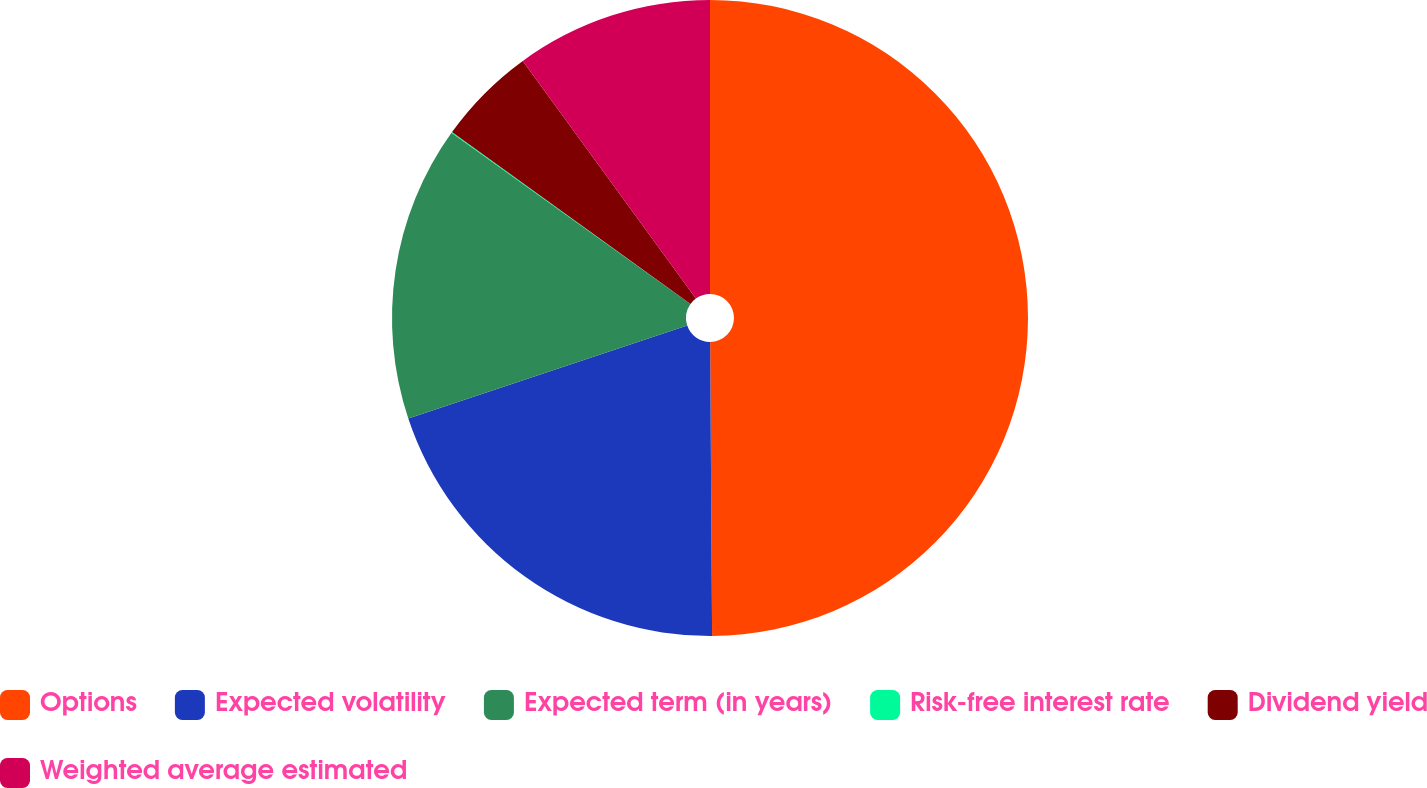Convert chart. <chart><loc_0><loc_0><loc_500><loc_500><pie_chart><fcel>Options<fcel>Expected volatility<fcel>Expected term (in years)<fcel>Risk-free interest rate<fcel>Dividend yield<fcel>Weighted average estimated<nl><fcel>49.9%<fcel>19.99%<fcel>15.01%<fcel>0.05%<fcel>5.04%<fcel>10.02%<nl></chart> 